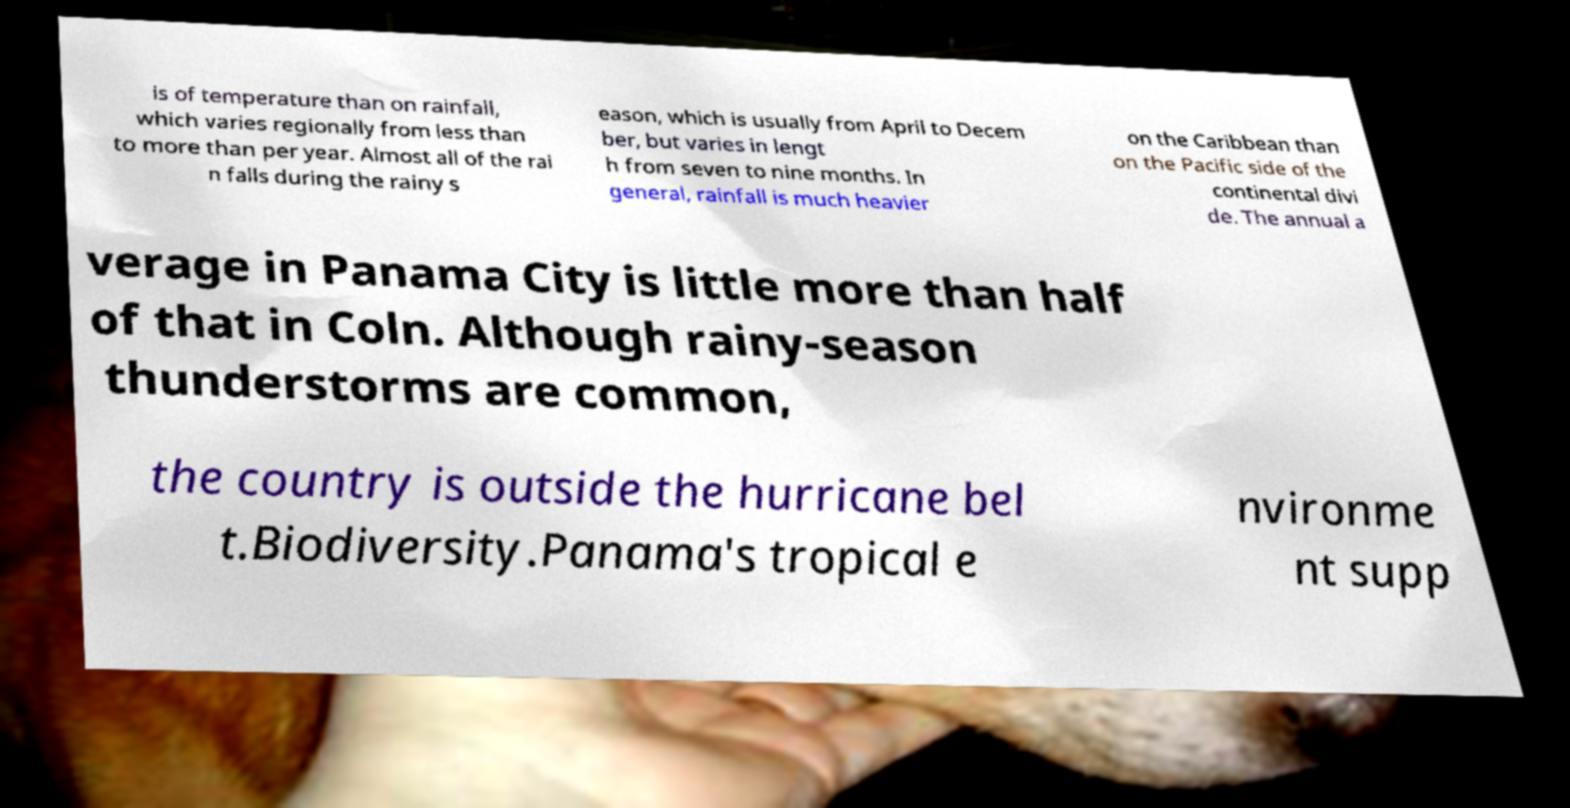Please identify and transcribe the text found in this image. is of temperature than on rainfall, which varies regionally from less than to more than per year. Almost all of the rai n falls during the rainy s eason, which is usually from April to Decem ber, but varies in lengt h from seven to nine months. In general, rainfall is much heavier on the Caribbean than on the Pacific side of the continental divi de. The annual a verage in Panama City is little more than half of that in Coln. Although rainy-season thunderstorms are common, the country is outside the hurricane bel t.Biodiversity.Panama's tropical e nvironme nt supp 